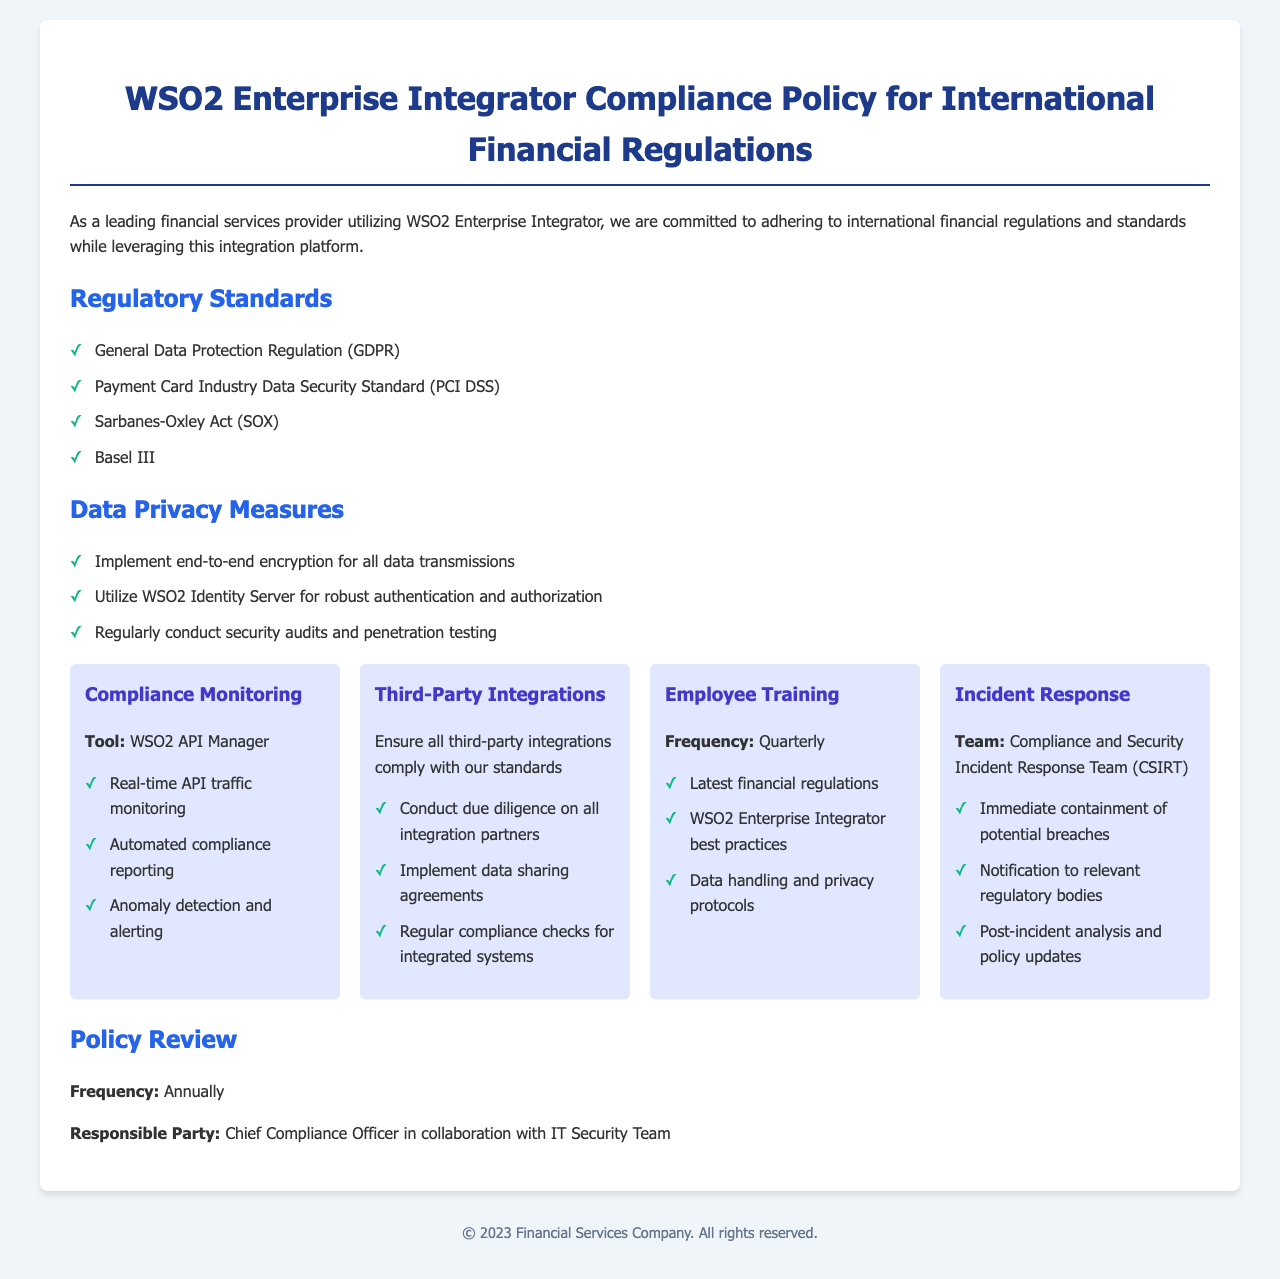What are the regulatory standards mentioned? The regulatory standards are listed in the document under their respective section.
Answer: GDPR, PCI DSS, SOX, Basel III How often is employee training conducted? The frequency of employee training is specified in the document.
Answer: Quarterly Who is responsible for the annual policy review? The document states who is responsible for reviewing the policy annually.
Answer: Chief Compliance Officer What tool is used for compliance monitoring? The specific tool mentioned for compliance monitoring can be found in the compliance monitoring section.
Answer: WSO2 API Manager What does the Incident Response Team do? The document outlines the main functions of the Incident Response Team in the incident response section.
Answer: Immediate containment of potential breaches What data privacy measure is implemented for transmissions? The document includes measures for data privacy, specifically regarding data transmissions.
Answer: End-to-end encryption What is the frequency of policy reviews? The document specifies how often the policy is reviewed.
Answer: Annually 